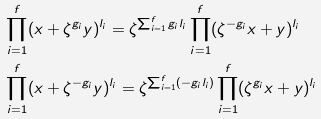Convert formula to latex. <formula><loc_0><loc_0><loc_500><loc_500>& \prod _ { i = 1 } ^ { f } ( x + \zeta ^ { g _ { i } } y ) ^ { l _ { i } } = \zeta ^ { \sum _ { i = 1 } ^ { f } g _ { i } l _ { i } } \prod _ { i = 1 } ^ { f } ( \zeta ^ { - g _ { i } } x + y ) ^ { l _ { i } } \\ & \prod _ { i = 1 } ^ { f } ( x + \zeta ^ { - g _ { i } } y ) ^ { l _ { i } } = \zeta ^ { \sum _ { i = 1 } ^ { f } ( - g _ { i } l _ { i } ) } \prod _ { i = 1 } ^ { f } ( \zeta ^ { g _ { i } } x + y ) ^ { l _ { i } }</formula> 